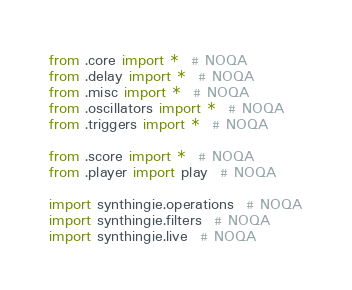Convert code to text. <code><loc_0><loc_0><loc_500><loc_500><_Python_>from .core import *  # NOQA
from .delay import *  # NOQA
from .misc import *  # NOQA
from .oscillators import *  # NOQA
from .triggers import *  # NOQA

from .score import *  # NOQA
from .player import play  # NOQA

import synthingie.operations  # NOQA
import synthingie.filters  # NOQA
import synthingie.live  # NOQA
</code> 